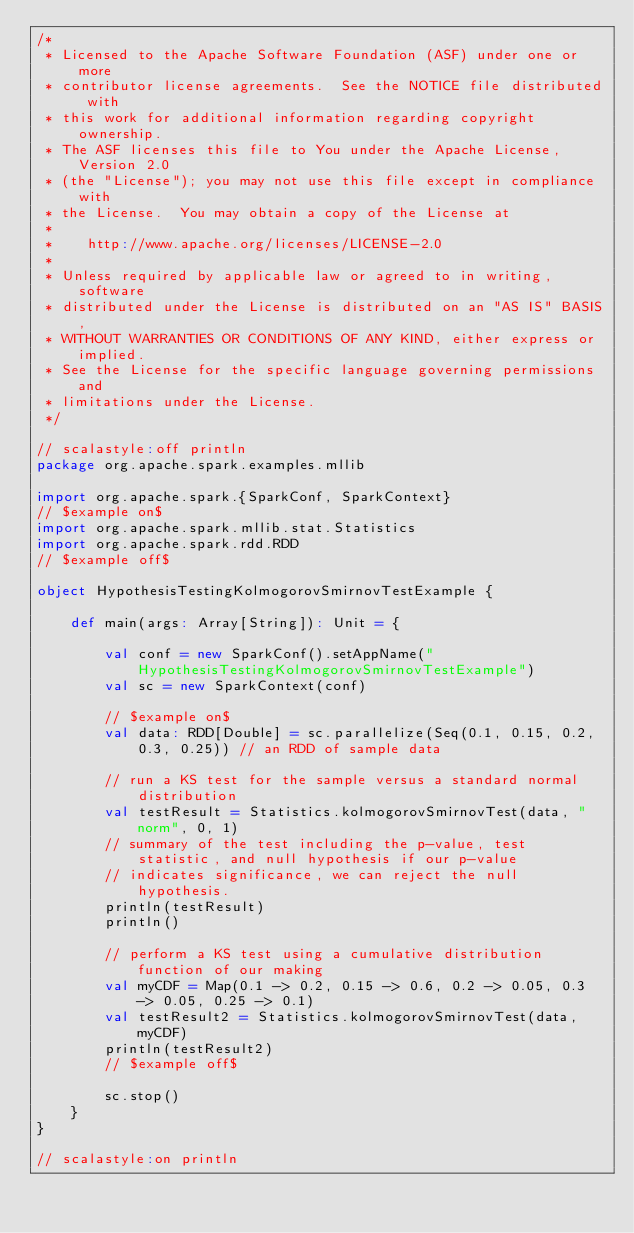Convert code to text. <code><loc_0><loc_0><loc_500><loc_500><_Scala_>/*
 * Licensed to the Apache Software Foundation (ASF) under one or more
 * contributor license agreements.  See the NOTICE file distributed with
 * this work for additional information regarding copyright ownership.
 * The ASF licenses this file to You under the Apache License, Version 2.0
 * (the "License"); you may not use this file except in compliance with
 * the License.  You may obtain a copy of the License at
 *
 *    http://www.apache.org/licenses/LICENSE-2.0
 *
 * Unless required by applicable law or agreed to in writing, software
 * distributed under the License is distributed on an "AS IS" BASIS,
 * WITHOUT WARRANTIES OR CONDITIONS OF ANY KIND, either express or implied.
 * See the License for the specific language governing permissions and
 * limitations under the License.
 */

// scalastyle:off println
package org.apache.spark.examples.mllib

import org.apache.spark.{SparkConf, SparkContext}
// $example on$
import org.apache.spark.mllib.stat.Statistics
import org.apache.spark.rdd.RDD
// $example off$

object HypothesisTestingKolmogorovSmirnovTestExample {

    def main(args: Array[String]): Unit = {

        val conf = new SparkConf().setAppName("HypothesisTestingKolmogorovSmirnovTestExample")
        val sc = new SparkContext(conf)

        // $example on$
        val data: RDD[Double] = sc.parallelize(Seq(0.1, 0.15, 0.2, 0.3, 0.25)) // an RDD of sample data

        // run a KS test for the sample versus a standard normal distribution
        val testResult = Statistics.kolmogorovSmirnovTest(data, "norm", 0, 1)
        // summary of the test including the p-value, test statistic, and null hypothesis if our p-value
        // indicates significance, we can reject the null hypothesis.
        println(testResult)
        println()

        // perform a KS test using a cumulative distribution function of our making
        val myCDF = Map(0.1 -> 0.2, 0.15 -> 0.6, 0.2 -> 0.05, 0.3 -> 0.05, 0.25 -> 0.1)
        val testResult2 = Statistics.kolmogorovSmirnovTest(data, myCDF)
        println(testResult2)
        // $example off$

        sc.stop()
    }
}

// scalastyle:on println

</code> 